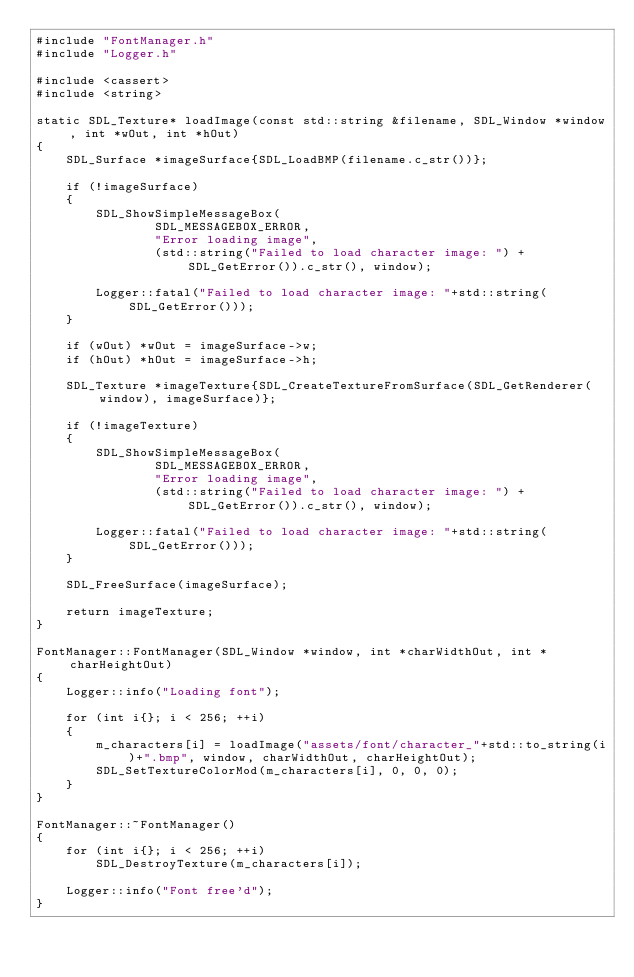Convert code to text. <code><loc_0><loc_0><loc_500><loc_500><_C++_>#include "FontManager.h"
#include "Logger.h"

#include <cassert>
#include <string>

static SDL_Texture* loadImage(const std::string &filename, SDL_Window *window, int *wOut, int *hOut)
{
    SDL_Surface *imageSurface{SDL_LoadBMP(filename.c_str())};

    if (!imageSurface)
    {
        SDL_ShowSimpleMessageBox(
                SDL_MESSAGEBOX_ERROR,
                "Error loading image",
                (std::string("Failed to load character image: ") + SDL_GetError()).c_str(), window);

        Logger::fatal("Failed to load character image: "+std::string(SDL_GetError()));
    }

    if (wOut) *wOut = imageSurface->w;
    if (hOut) *hOut = imageSurface->h;

    SDL_Texture *imageTexture{SDL_CreateTextureFromSurface(SDL_GetRenderer(window), imageSurface)};

    if (!imageTexture)
    {
        SDL_ShowSimpleMessageBox(
                SDL_MESSAGEBOX_ERROR,
                "Error loading image",
                (std::string("Failed to load character image: ") + SDL_GetError()).c_str(), window);

        Logger::fatal("Failed to load character image: "+std::string(SDL_GetError()));
    }

    SDL_FreeSurface(imageSurface);

    return imageTexture;
}

FontManager::FontManager(SDL_Window *window, int *charWidthOut, int *charHeightOut)
{
    Logger::info("Loading font");

    for (int i{}; i < 256; ++i)
    {
        m_characters[i] = loadImage("assets/font/character_"+std::to_string(i)+".bmp", window, charWidthOut, charHeightOut);
        SDL_SetTextureColorMod(m_characters[i], 0, 0, 0);
    }
}

FontManager::~FontManager()
{
    for (int i{}; i < 256; ++i)
        SDL_DestroyTexture(m_characters[i]);

    Logger::info("Font free'd");
}

</code> 